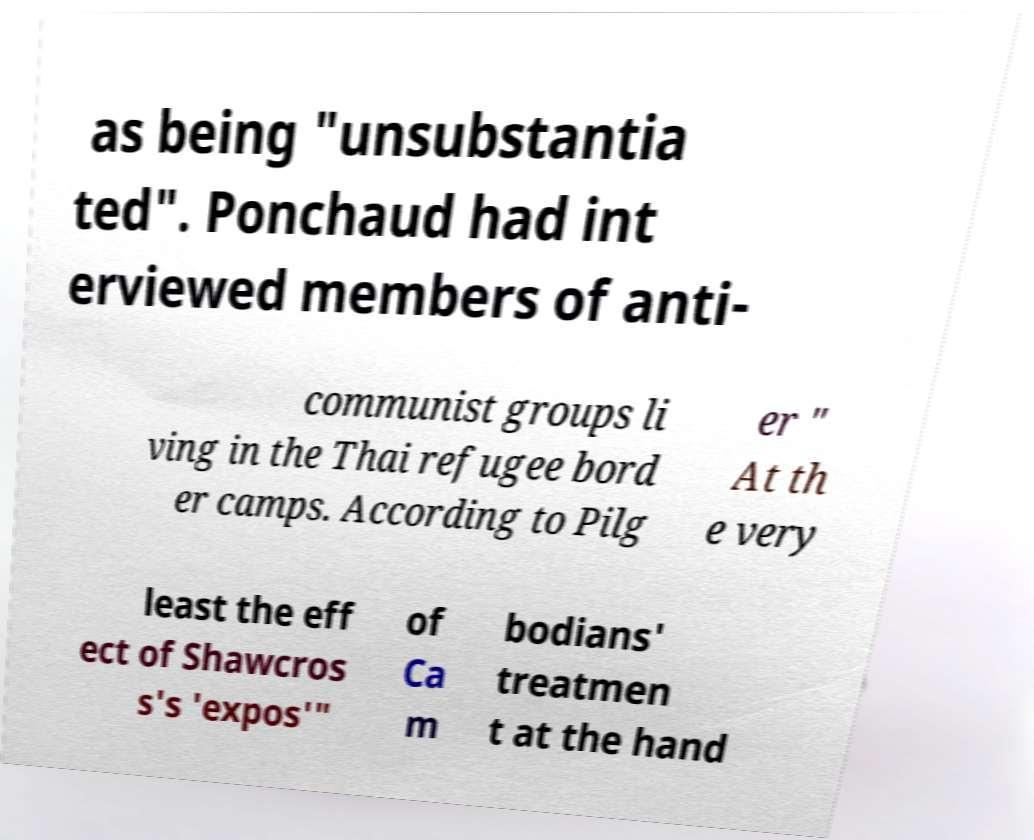Please read and relay the text visible in this image. What does it say? as being "unsubstantia ted". Ponchaud had int erviewed members of anti- communist groups li ving in the Thai refugee bord er camps. According to Pilg er " At th e very least the eff ect of Shawcros s's 'expos'" of Ca m bodians' treatmen t at the hand 